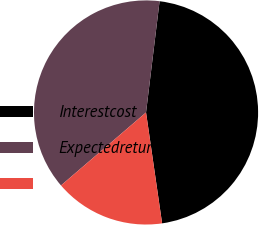<chart> <loc_0><loc_0><loc_500><loc_500><pie_chart><fcel>Interestcost<fcel>Expectedreturnonplanassets<fcel>Unnamed: 2<nl><fcel>45.78%<fcel>38.22%<fcel>16.0%<nl></chart> 